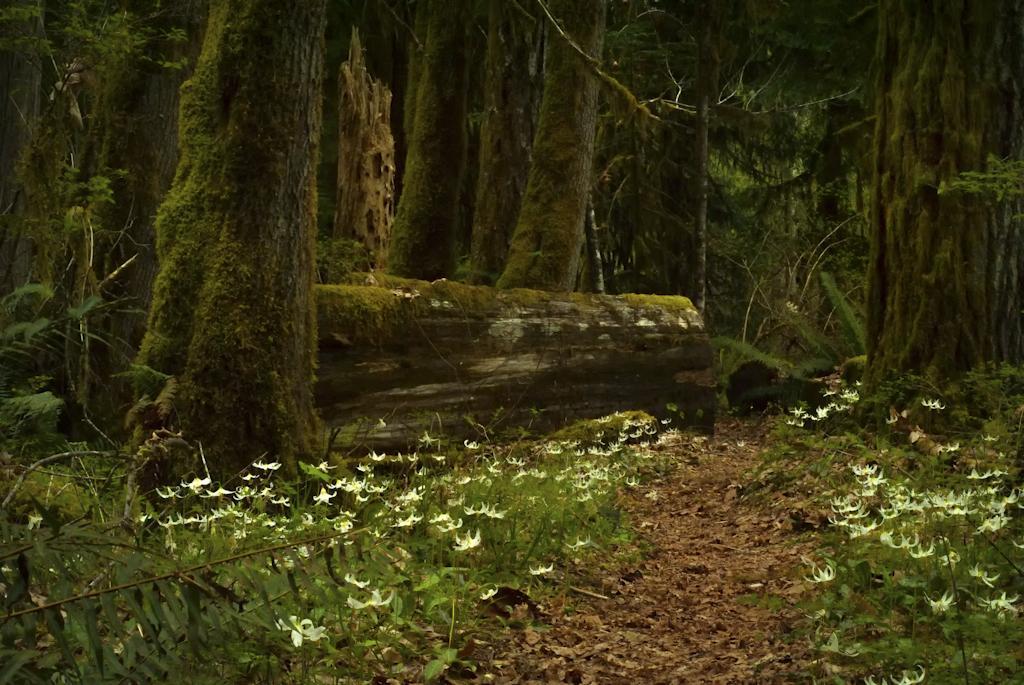Describe this image in one or two sentences. In this picture we can see plants, flowers, trees and tree trunks. 